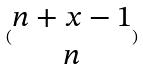Convert formula to latex. <formula><loc_0><loc_0><loc_500><loc_500>( \begin{matrix} n + x - 1 \\ n \end{matrix} )</formula> 